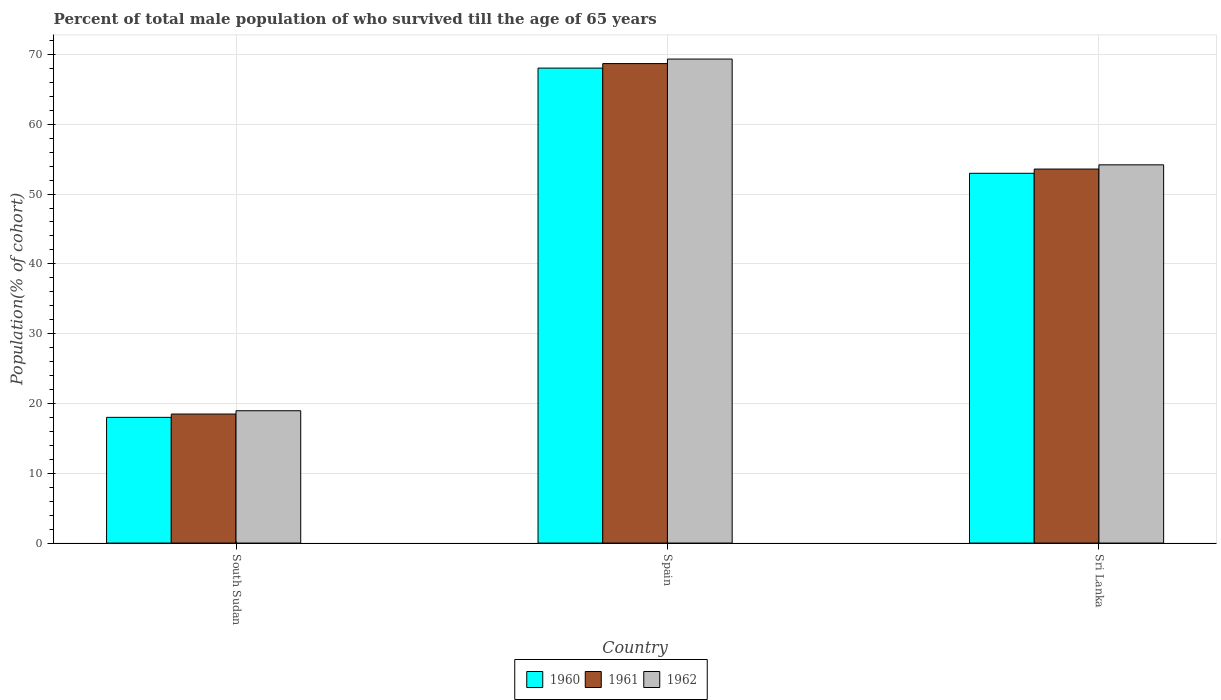How many different coloured bars are there?
Your answer should be very brief. 3. How many groups of bars are there?
Provide a succinct answer. 3. Are the number of bars per tick equal to the number of legend labels?
Your answer should be very brief. Yes. Are the number of bars on each tick of the X-axis equal?
Your answer should be compact. Yes. How many bars are there on the 3rd tick from the left?
Keep it short and to the point. 3. How many bars are there on the 3rd tick from the right?
Offer a very short reply. 3. What is the label of the 3rd group of bars from the left?
Provide a short and direct response. Sri Lanka. What is the percentage of total male population who survived till the age of 65 years in 1962 in Sri Lanka?
Make the answer very short. 54.19. Across all countries, what is the maximum percentage of total male population who survived till the age of 65 years in 1961?
Keep it short and to the point. 68.69. Across all countries, what is the minimum percentage of total male population who survived till the age of 65 years in 1961?
Your answer should be very brief. 18.48. In which country was the percentage of total male population who survived till the age of 65 years in 1962 maximum?
Make the answer very short. Spain. In which country was the percentage of total male population who survived till the age of 65 years in 1960 minimum?
Provide a short and direct response. South Sudan. What is the total percentage of total male population who survived till the age of 65 years in 1962 in the graph?
Offer a very short reply. 142.48. What is the difference between the percentage of total male population who survived till the age of 65 years in 1962 in Spain and that in Sri Lanka?
Make the answer very short. 15.15. What is the difference between the percentage of total male population who survived till the age of 65 years in 1962 in South Sudan and the percentage of total male population who survived till the age of 65 years in 1960 in Sri Lanka?
Give a very brief answer. -34.02. What is the average percentage of total male population who survived till the age of 65 years in 1962 per country?
Provide a short and direct response. 47.49. What is the difference between the percentage of total male population who survived till the age of 65 years of/in 1960 and percentage of total male population who survived till the age of 65 years of/in 1962 in Spain?
Provide a short and direct response. -1.29. What is the ratio of the percentage of total male population who survived till the age of 65 years in 1962 in South Sudan to that in Spain?
Your answer should be very brief. 0.27. Is the difference between the percentage of total male population who survived till the age of 65 years in 1960 in Spain and Sri Lanka greater than the difference between the percentage of total male population who survived till the age of 65 years in 1962 in Spain and Sri Lanka?
Make the answer very short. No. What is the difference between the highest and the second highest percentage of total male population who survived till the age of 65 years in 1962?
Your answer should be very brief. -50.38. What is the difference between the highest and the lowest percentage of total male population who survived till the age of 65 years in 1962?
Offer a terse response. 50.38. In how many countries, is the percentage of total male population who survived till the age of 65 years in 1960 greater than the average percentage of total male population who survived till the age of 65 years in 1960 taken over all countries?
Your response must be concise. 2. What does the 2nd bar from the left in Spain represents?
Provide a succinct answer. 1961. What does the 3rd bar from the right in South Sudan represents?
Give a very brief answer. 1960. Is it the case that in every country, the sum of the percentage of total male population who survived till the age of 65 years in 1960 and percentage of total male population who survived till the age of 65 years in 1961 is greater than the percentage of total male population who survived till the age of 65 years in 1962?
Your response must be concise. Yes. Are all the bars in the graph horizontal?
Ensure brevity in your answer.  No. How many countries are there in the graph?
Ensure brevity in your answer.  3. Are the values on the major ticks of Y-axis written in scientific E-notation?
Offer a terse response. No. Does the graph contain any zero values?
Offer a very short reply. No. Where does the legend appear in the graph?
Provide a short and direct response. Bottom center. How many legend labels are there?
Provide a succinct answer. 3. How are the legend labels stacked?
Offer a very short reply. Horizontal. What is the title of the graph?
Make the answer very short. Percent of total male population of who survived till the age of 65 years. What is the label or title of the X-axis?
Your answer should be compact. Country. What is the label or title of the Y-axis?
Make the answer very short. Population(% of cohort). What is the Population(% of cohort) of 1960 in South Sudan?
Provide a short and direct response. 18.01. What is the Population(% of cohort) in 1961 in South Sudan?
Keep it short and to the point. 18.48. What is the Population(% of cohort) of 1962 in South Sudan?
Your answer should be very brief. 18.96. What is the Population(% of cohort) of 1960 in Spain?
Your answer should be very brief. 68.04. What is the Population(% of cohort) in 1961 in Spain?
Offer a terse response. 68.69. What is the Population(% of cohort) of 1962 in Spain?
Keep it short and to the point. 69.34. What is the Population(% of cohort) of 1960 in Sri Lanka?
Your answer should be very brief. 52.97. What is the Population(% of cohort) of 1961 in Sri Lanka?
Your answer should be compact. 53.58. What is the Population(% of cohort) in 1962 in Sri Lanka?
Your answer should be compact. 54.19. Across all countries, what is the maximum Population(% of cohort) of 1960?
Offer a very short reply. 68.04. Across all countries, what is the maximum Population(% of cohort) in 1961?
Offer a terse response. 68.69. Across all countries, what is the maximum Population(% of cohort) in 1962?
Provide a short and direct response. 69.34. Across all countries, what is the minimum Population(% of cohort) of 1960?
Offer a very short reply. 18.01. Across all countries, what is the minimum Population(% of cohort) in 1961?
Your response must be concise. 18.48. Across all countries, what is the minimum Population(% of cohort) in 1962?
Your answer should be very brief. 18.96. What is the total Population(% of cohort) in 1960 in the graph?
Keep it short and to the point. 139.03. What is the total Population(% of cohort) of 1961 in the graph?
Make the answer very short. 140.75. What is the total Population(% of cohort) of 1962 in the graph?
Provide a succinct answer. 142.48. What is the difference between the Population(% of cohort) in 1960 in South Sudan and that in Spain?
Keep it short and to the point. -50.03. What is the difference between the Population(% of cohort) of 1961 in South Sudan and that in Spain?
Keep it short and to the point. -50.21. What is the difference between the Population(% of cohort) of 1962 in South Sudan and that in Spain?
Provide a short and direct response. -50.38. What is the difference between the Population(% of cohort) of 1960 in South Sudan and that in Sri Lanka?
Keep it short and to the point. -34.97. What is the difference between the Population(% of cohort) in 1961 in South Sudan and that in Sri Lanka?
Your answer should be very brief. -35.1. What is the difference between the Population(% of cohort) of 1962 in South Sudan and that in Sri Lanka?
Offer a very short reply. -35.23. What is the difference between the Population(% of cohort) of 1960 in Spain and that in Sri Lanka?
Offer a very short reply. 15.07. What is the difference between the Population(% of cohort) in 1961 in Spain and that in Sri Lanka?
Keep it short and to the point. 15.11. What is the difference between the Population(% of cohort) of 1962 in Spain and that in Sri Lanka?
Make the answer very short. 15.15. What is the difference between the Population(% of cohort) of 1960 in South Sudan and the Population(% of cohort) of 1961 in Spain?
Keep it short and to the point. -50.68. What is the difference between the Population(% of cohort) of 1960 in South Sudan and the Population(% of cohort) of 1962 in Spain?
Provide a short and direct response. -51.33. What is the difference between the Population(% of cohort) in 1961 in South Sudan and the Population(% of cohort) in 1962 in Spain?
Make the answer very short. -50.86. What is the difference between the Population(% of cohort) of 1960 in South Sudan and the Population(% of cohort) of 1961 in Sri Lanka?
Ensure brevity in your answer.  -35.57. What is the difference between the Population(% of cohort) of 1960 in South Sudan and the Population(% of cohort) of 1962 in Sri Lanka?
Offer a terse response. -36.18. What is the difference between the Population(% of cohort) of 1961 in South Sudan and the Population(% of cohort) of 1962 in Sri Lanka?
Provide a succinct answer. -35.7. What is the difference between the Population(% of cohort) of 1960 in Spain and the Population(% of cohort) of 1961 in Sri Lanka?
Offer a terse response. 14.46. What is the difference between the Population(% of cohort) of 1960 in Spain and the Population(% of cohort) of 1962 in Sri Lanka?
Provide a short and direct response. 13.86. What is the difference between the Population(% of cohort) in 1961 in Spain and the Population(% of cohort) in 1962 in Sri Lanka?
Make the answer very short. 14.5. What is the average Population(% of cohort) in 1960 per country?
Offer a terse response. 46.34. What is the average Population(% of cohort) in 1961 per country?
Give a very brief answer. 46.92. What is the average Population(% of cohort) in 1962 per country?
Make the answer very short. 47.49. What is the difference between the Population(% of cohort) of 1960 and Population(% of cohort) of 1961 in South Sudan?
Offer a terse response. -0.47. What is the difference between the Population(% of cohort) in 1960 and Population(% of cohort) in 1962 in South Sudan?
Provide a succinct answer. -0.95. What is the difference between the Population(% of cohort) of 1961 and Population(% of cohort) of 1962 in South Sudan?
Provide a short and direct response. -0.47. What is the difference between the Population(% of cohort) of 1960 and Population(% of cohort) of 1961 in Spain?
Provide a short and direct response. -0.65. What is the difference between the Population(% of cohort) in 1960 and Population(% of cohort) in 1962 in Spain?
Your answer should be very brief. -1.29. What is the difference between the Population(% of cohort) in 1961 and Population(% of cohort) in 1962 in Spain?
Give a very brief answer. -0.65. What is the difference between the Population(% of cohort) in 1960 and Population(% of cohort) in 1961 in Sri Lanka?
Your answer should be very brief. -0.61. What is the difference between the Population(% of cohort) in 1960 and Population(% of cohort) in 1962 in Sri Lanka?
Offer a terse response. -1.21. What is the difference between the Population(% of cohort) in 1961 and Population(% of cohort) in 1962 in Sri Lanka?
Your answer should be very brief. -0.61. What is the ratio of the Population(% of cohort) in 1960 in South Sudan to that in Spain?
Offer a very short reply. 0.26. What is the ratio of the Population(% of cohort) in 1961 in South Sudan to that in Spain?
Provide a short and direct response. 0.27. What is the ratio of the Population(% of cohort) of 1962 in South Sudan to that in Spain?
Your answer should be very brief. 0.27. What is the ratio of the Population(% of cohort) in 1960 in South Sudan to that in Sri Lanka?
Your answer should be compact. 0.34. What is the ratio of the Population(% of cohort) in 1961 in South Sudan to that in Sri Lanka?
Provide a short and direct response. 0.34. What is the ratio of the Population(% of cohort) of 1962 in South Sudan to that in Sri Lanka?
Offer a very short reply. 0.35. What is the ratio of the Population(% of cohort) of 1960 in Spain to that in Sri Lanka?
Ensure brevity in your answer.  1.28. What is the ratio of the Population(% of cohort) of 1961 in Spain to that in Sri Lanka?
Make the answer very short. 1.28. What is the ratio of the Population(% of cohort) in 1962 in Spain to that in Sri Lanka?
Provide a short and direct response. 1.28. What is the difference between the highest and the second highest Population(% of cohort) in 1960?
Provide a succinct answer. 15.07. What is the difference between the highest and the second highest Population(% of cohort) in 1961?
Ensure brevity in your answer.  15.11. What is the difference between the highest and the second highest Population(% of cohort) of 1962?
Offer a very short reply. 15.15. What is the difference between the highest and the lowest Population(% of cohort) in 1960?
Give a very brief answer. 50.03. What is the difference between the highest and the lowest Population(% of cohort) of 1961?
Provide a short and direct response. 50.21. What is the difference between the highest and the lowest Population(% of cohort) in 1962?
Make the answer very short. 50.38. 